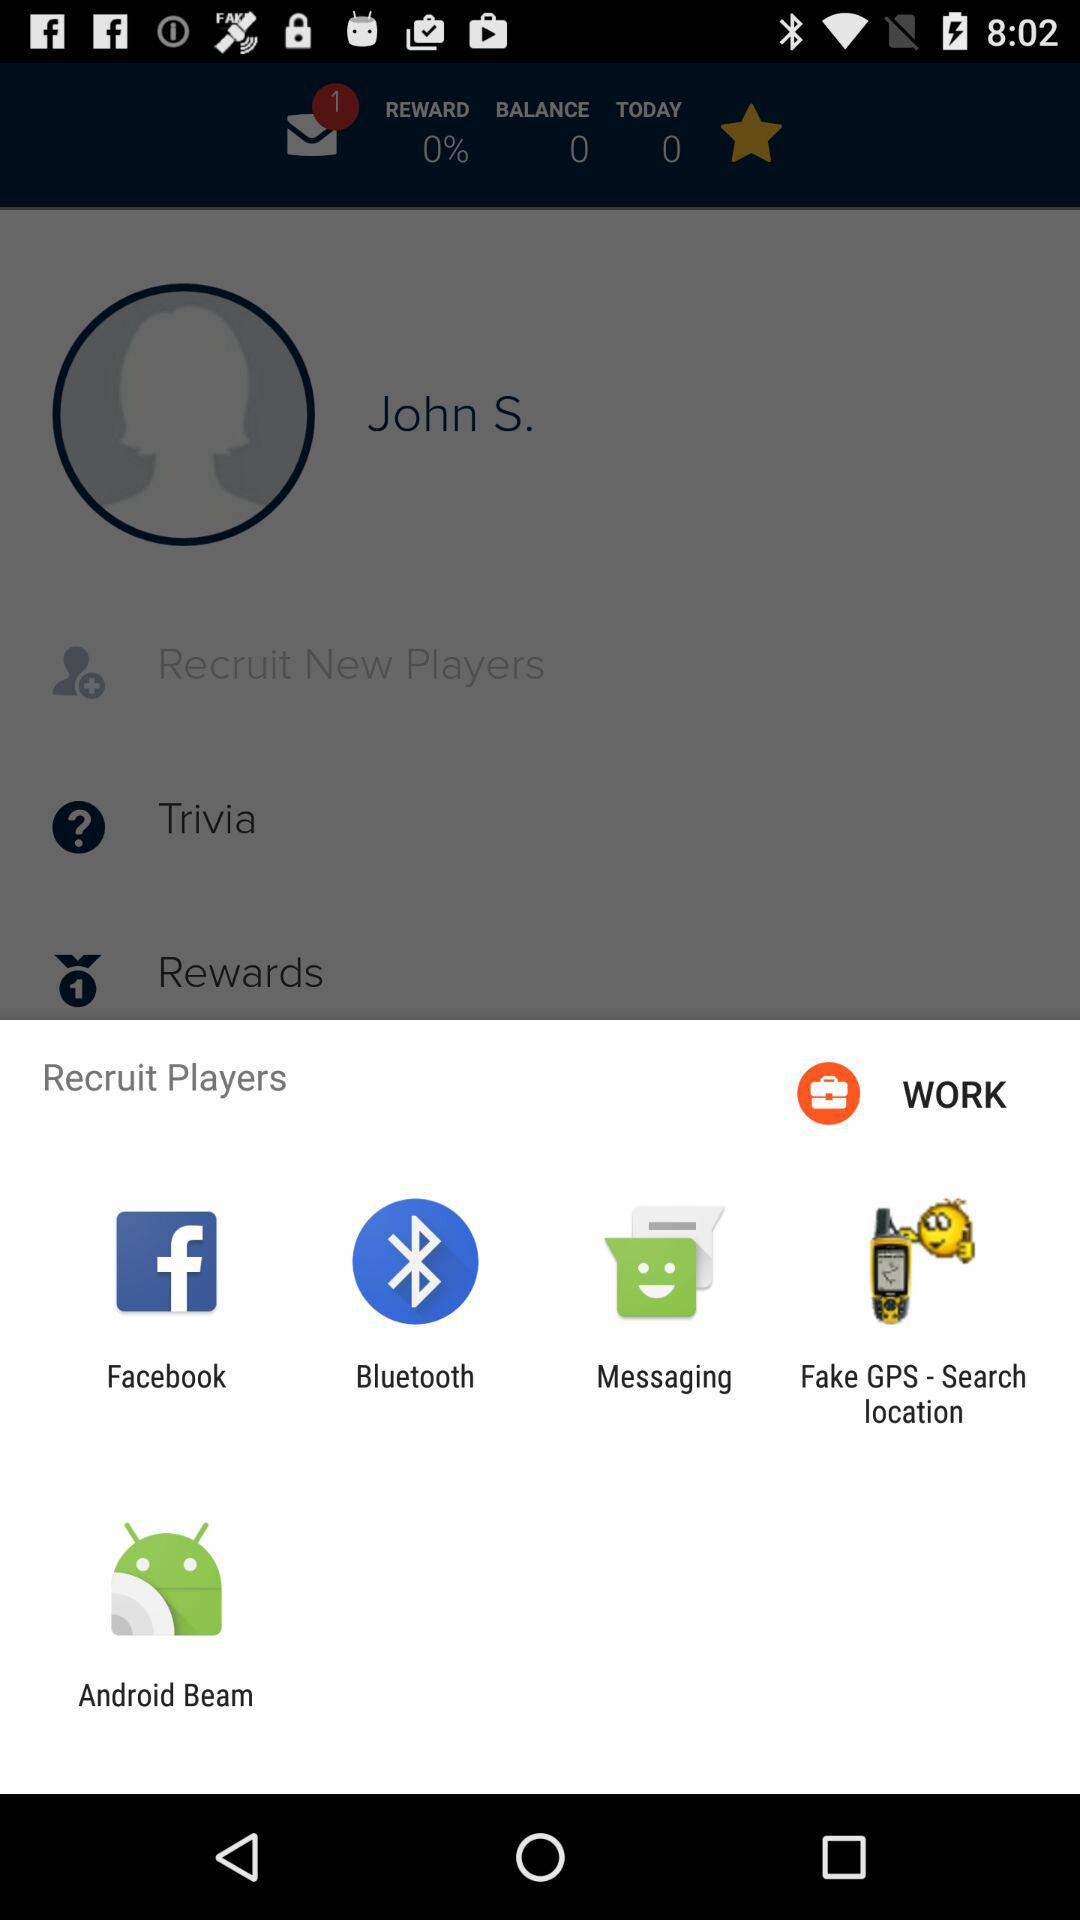What is the difference between the number of today's rewards and the total rewards?
Answer the question using a single word or phrase. 0 